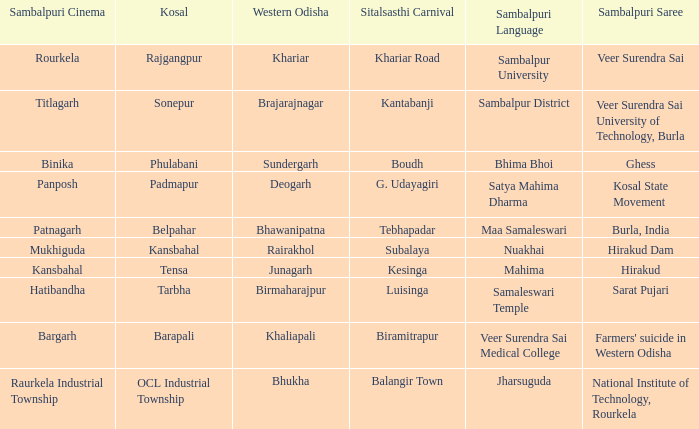What is the sitalsasthi event including hirakud as sambalpuri saree? Kesinga. 